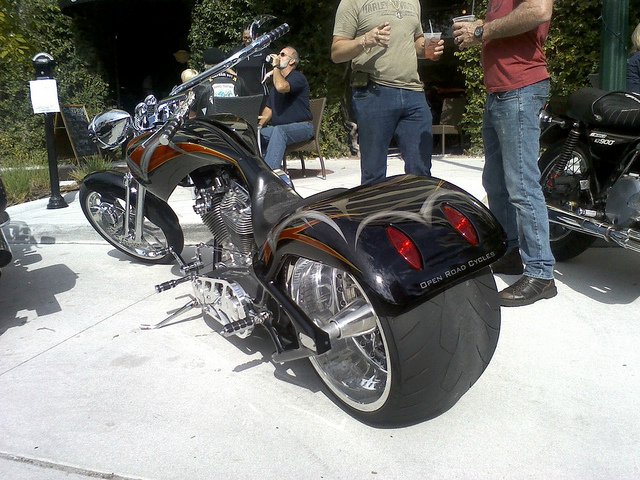Extract all visible text content from this image. OPEN ROAD CYCLES 